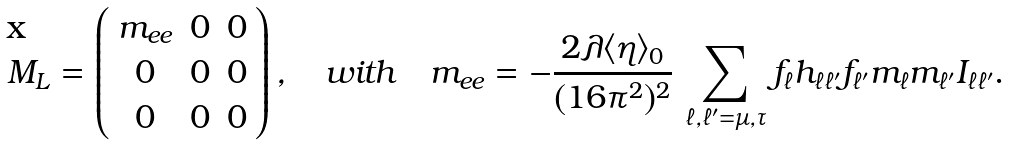Convert formula to latex. <formula><loc_0><loc_0><loc_500><loc_500>M _ { L } = \left ( \begin{array} { c c c } m _ { e e } & 0 & 0 \\ 0 & 0 & 0 \\ 0 & 0 & 0 \end{array} \right ) , \quad w i t h \quad m _ { e e } = - \frac { 2 \lambda \langle \eta \rangle _ { 0 } } { ( 1 6 \pi ^ { 2 } ) ^ { 2 } } \, \sum _ { \ell , \ell ^ { \prime } = \mu , \tau } f _ { \ell } h _ { \ell \ell ^ { \prime } } f _ { \ell ^ { \prime } } m _ { \ell } m _ { \ell ^ { \prime } } I _ { \ell \ell ^ { \prime } } .</formula> 